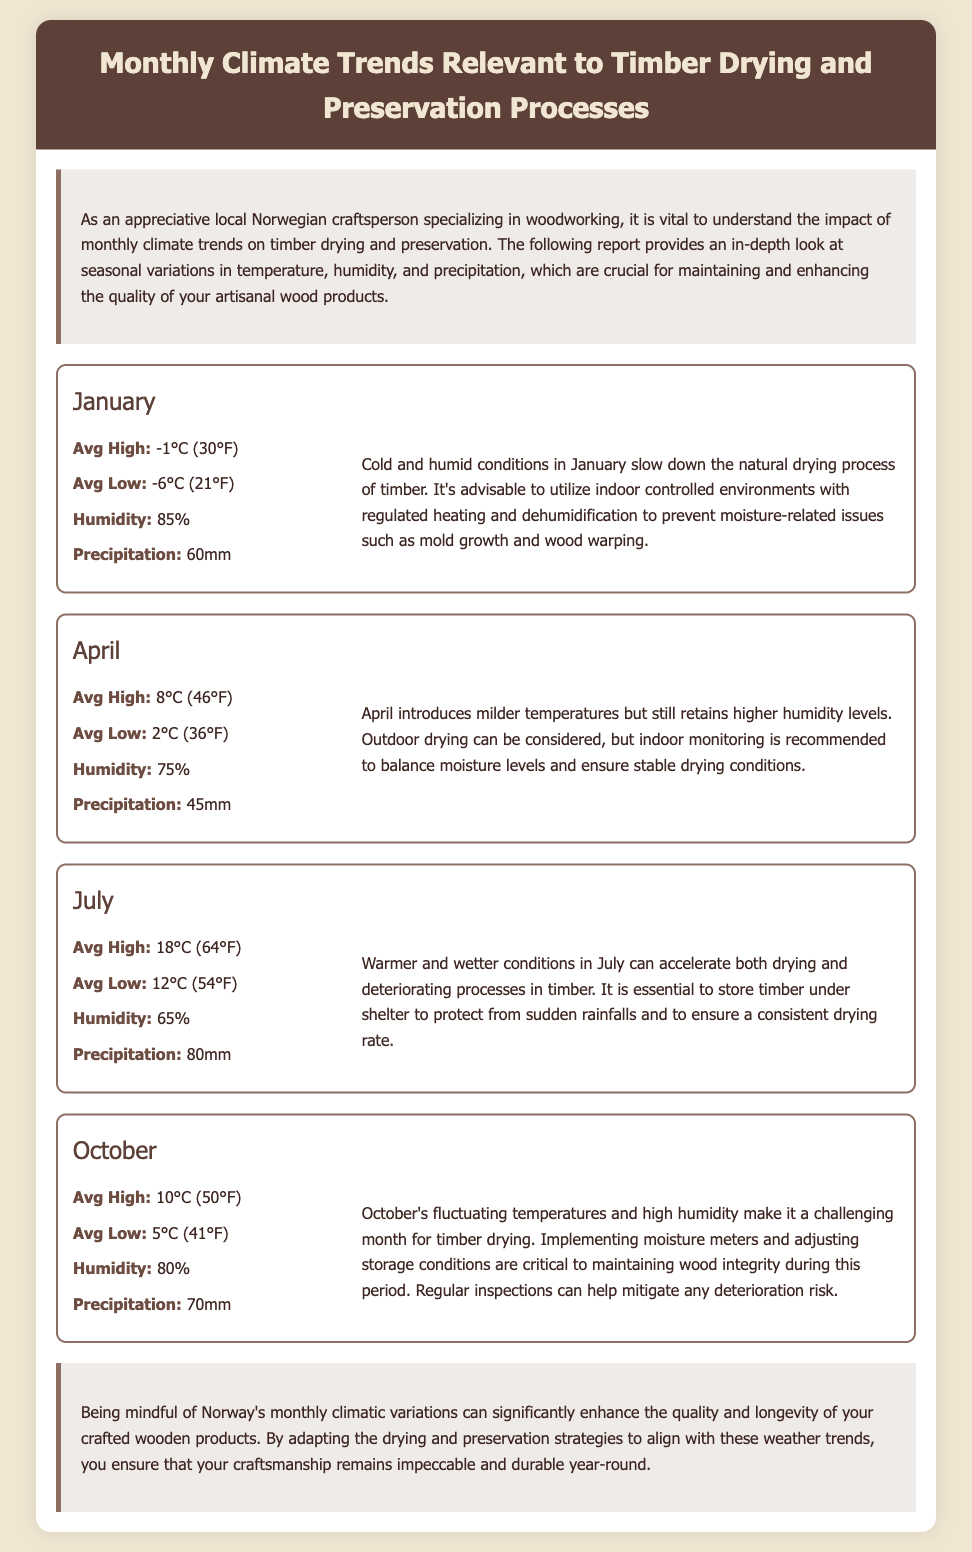What is the average high temperature in January? The average high temperature in January is explicitly stated in the document as -1°C (30°F).
Answer: -1°C (30°F) What is the average low temperature in July? The average low temperature in July is clearly mentioned in the document as 12°C (54°F).
Answer: 12°C (54°F) What percentage is the humidity in October? The humidity figure for October is presented in the document as 80%.
Answer: 80% What is the total precipitation in April? The total precipitation in April is given as 45mm in the document.
Answer: 45mm How does January's climate affect timber drying? The document indicates that cold and humid conditions in January slow down the natural drying process of timber.
Answer: Slows down What is the average high temperature in July compared to October? The average high temperature in July is 18°C (64°F), whereas in October it is 10°C (50°F), which shows that July is warmer than October.
Answer: Warmer What preservation strategy is recommended for October? The document suggests implementing moisture meters and adjusting storage conditions as critical for October.
Answer: Moisture meters Which month has the highest average humidity? The highest average humidity is indicated for January at 85%.
Answer: January What key action should be taken in July regarding timber storage? It is essential to store timber under shelter to protect it from sudden rainfalls in July.
Answer: Store under shelter 